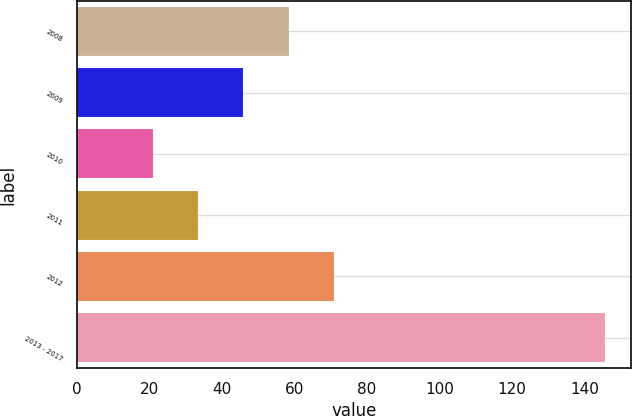Convert chart to OTSL. <chart><loc_0><loc_0><loc_500><loc_500><bar_chart><fcel>2008<fcel>2009<fcel>2010<fcel>2011<fcel>2012<fcel>2013 - 2017<nl><fcel>58.45<fcel>46<fcel>21.1<fcel>33.55<fcel>70.9<fcel>145.6<nl></chart> 